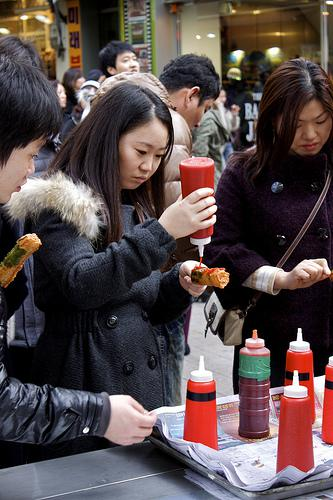Question: what race are the people?
Choices:
A. African.
B. Asian.
C. Hispanic.
D. Caucasian.
Answer with the letter. Answer: B Question: what are the people doing?
Choices:
A. Drinking.
B. Singing.
C. Eating.
D. Sleeping.
Answer with the letter. Answer: C Question: what color are the bottles?
Choices:
A. White.
B. Red.
C. Green.
D. Blue.
Answer with the letter. Answer: B 